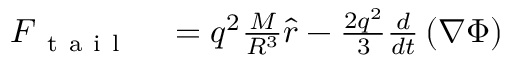<formula> <loc_0><loc_0><loc_500><loc_500>\begin{array} { r l } { F _ { t a i l } } & = q ^ { 2 } \frac { M } { R ^ { 3 } } \hat { r } - \frac { 2 q ^ { 2 } } { 3 } \frac { d } { d t } \left ( \nabla \Phi \right ) } \end{array}</formula> 